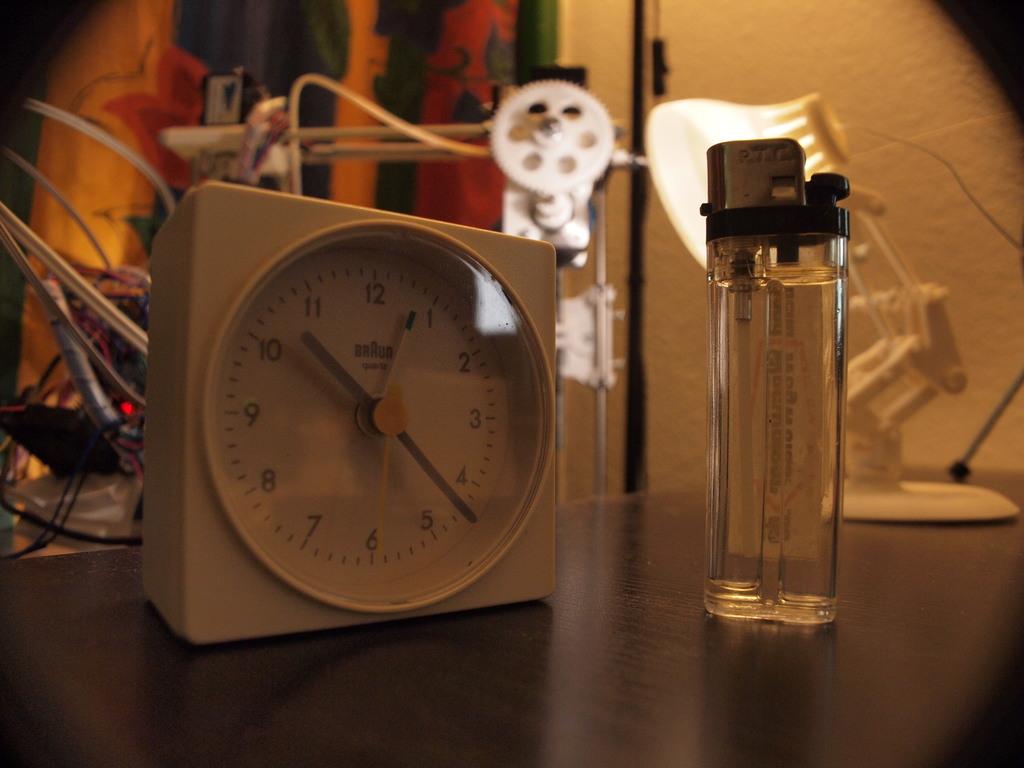What is the time shown?
Your answer should be very brief. 10:22. What number is the small hand pointing to?
Make the answer very short. 10. 